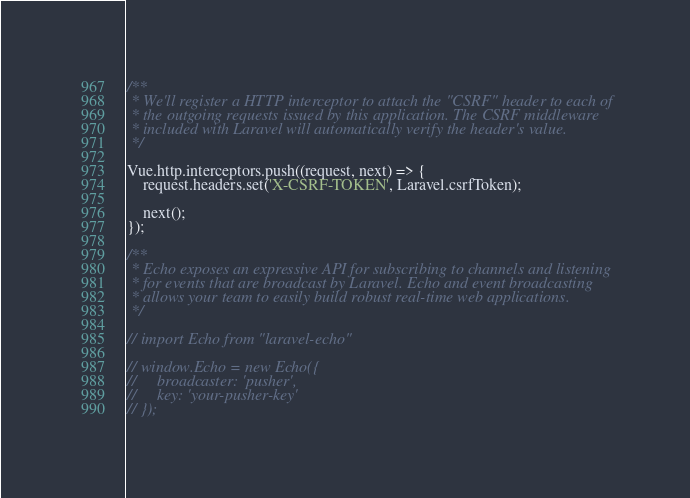Convert code to text. <code><loc_0><loc_0><loc_500><loc_500><_JavaScript_>/**
 * We'll register a HTTP interceptor to attach the "CSRF" header to each of
 * the outgoing requests issued by this application. The CSRF middleware
 * included with Laravel will automatically verify the header's value.
 */

Vue.http.interceptors.push((request, next) => {
    request.headers.set('X-CSRF-TOKEN', Laravel.csrfToken);

    next();
});

/**
 * Echo exposes an expressive API for subscribing to channels and listening
 * for events that are broadcast by Laravel. Echo and event broadcasting
 * allows your team to easily build robust real-time web applications.
 */

// import Echo from "laravel-echo"

// window.Echo = new Echo({
//     broadcaster: 'pusher',
//     key: 'your-pusher-key'
// });
</code> 